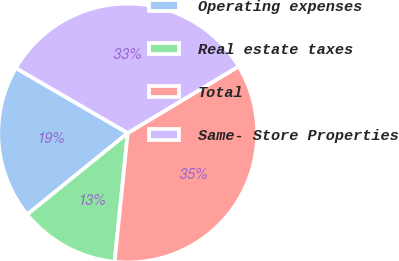<chart> <loc_0><loc_0><loc_500><loc_500><pie_chart><fcel>Operating expenses<fcel>Real estate taxes<fcel>Total<fcel>Same- Store Properties<nl><fcel>19.22%<fcel>12.54%<fcel>35.23%<fcel>33.01%<nl></chart> 